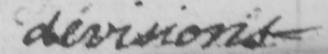Transcribe the text shown in this historical manuscript line. divisions _ 